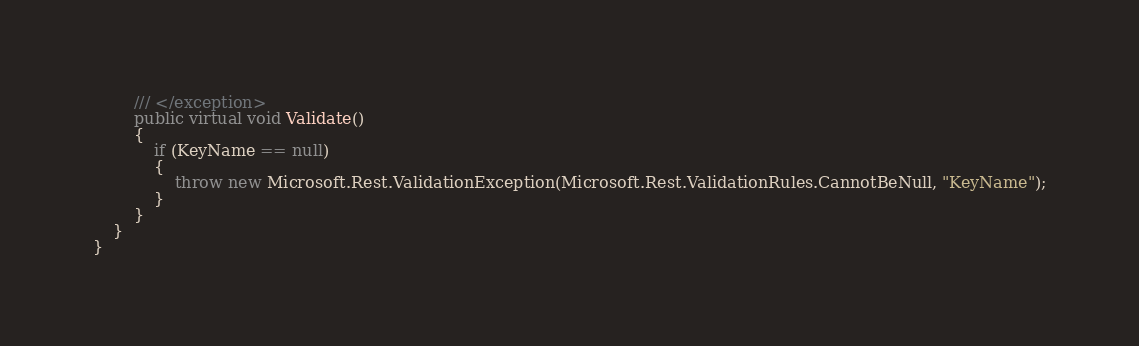<code> <loc_0><loc_0><loc_500><loc_500><_C#_>        /// </exception>
        public virtual void Validate()
        {
            if (KeyName == null)
            {
                throw new Microsoft.Rest.ValidationException(Microsoft.Rest.ValidationRules.CannotBeNull, "KeyName");
            }
        }
    }
}
</code> 